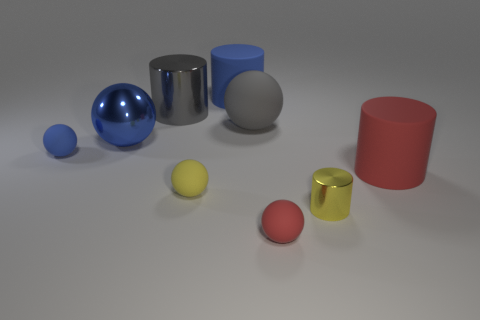What number of things are either big blue metallic blocks or matte balls?
Ensure brevity in your answer.  4. What number of other objects are the same size as the yellow cylinder?
Ensure brevity in your answer.  3. What number of big objects are both to the left of the tiny yellow ball and behind the gray rubber ball?
Ensure brevity in your answer.  1. There is a rubber thing that is left of the yellow rubber sphere; is it the same size as the metal cylinder that is behind the small blue rubber sphere?
Provide a short and direct response. No. There is a red thing that is to the left of the red matte cylinder; how big is it?
Ensure brevity in your answer.  Small. What number of objects are rubber balls that are in front of the big red thing or metal cylinders on the right side of the big blue matte object?
Make the answer very short. 3. Is there anything else that has the same color as the large rubber ball?
Ensure brevity in your answer.  Yes. Are there an equal number of tiny yellow objects that are to the right of the small yellow ball and tiny yellow shiny things behind the large gray rubber ball?
Your response must be concise. No. Are there more metallic spheres that are on the right side of the big blue metallic thing than big spheres?
Make the answer very short. No. What number of objects are cylinders that are on the left side of the red cylinder or red matte cylinders?
Give a very brief answer. 4. 